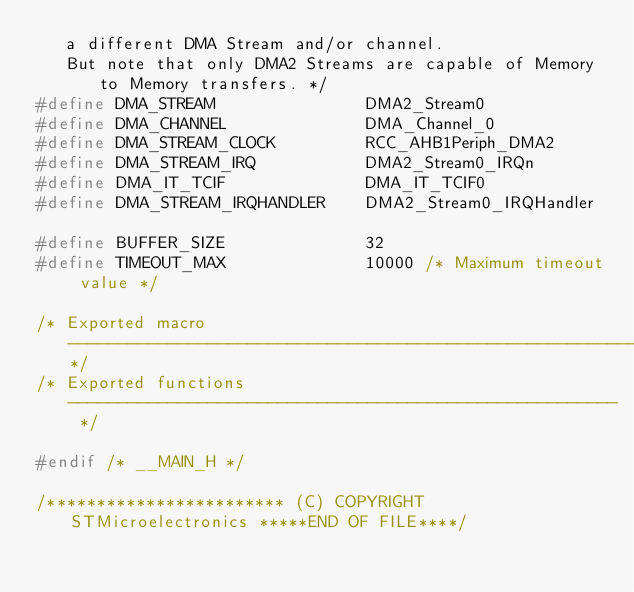Convert code to text. <code><loc_0><loc_0><loc_500><loc_500><_C_>   a different DMA Stream and/or channel.
   But note that only DMA2 Streams are capable of Memory to Memory transfers. */
#define DMA_STREAM               DMA2_Stream0
#define DMA_CHANNEL              DMA_Channel_0
#define DMA_STREAM_CLOCK         RCC_AHB1Periph_DMA2 
#define DMA_STREAM_IRQ           DMA2_Stream0_IRQn
#define DMA_IT_TCIF              DMA_IT_TCIF0
#define DMA_STREAM_IRQHANDLER    DMA2_Stream0_IRQHandler

#define BUFFER_SIZE              32
#define TIMEOUT_MAX              10000 /* Maximum timeout value */

/* Exported macro ------------------------------------------------------------*/
/* Exported functions ------------------------------------------------------- */

#endif /* __MAIN_H */

/************************ (C) COPYRIGHT STMicroelectronics *****END OF FILE****/
</code> 